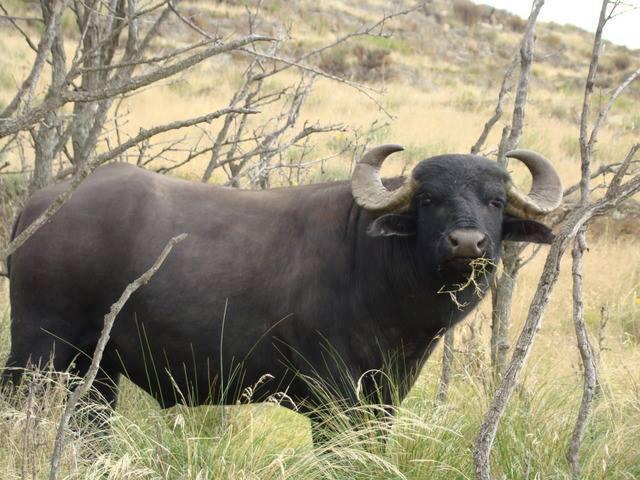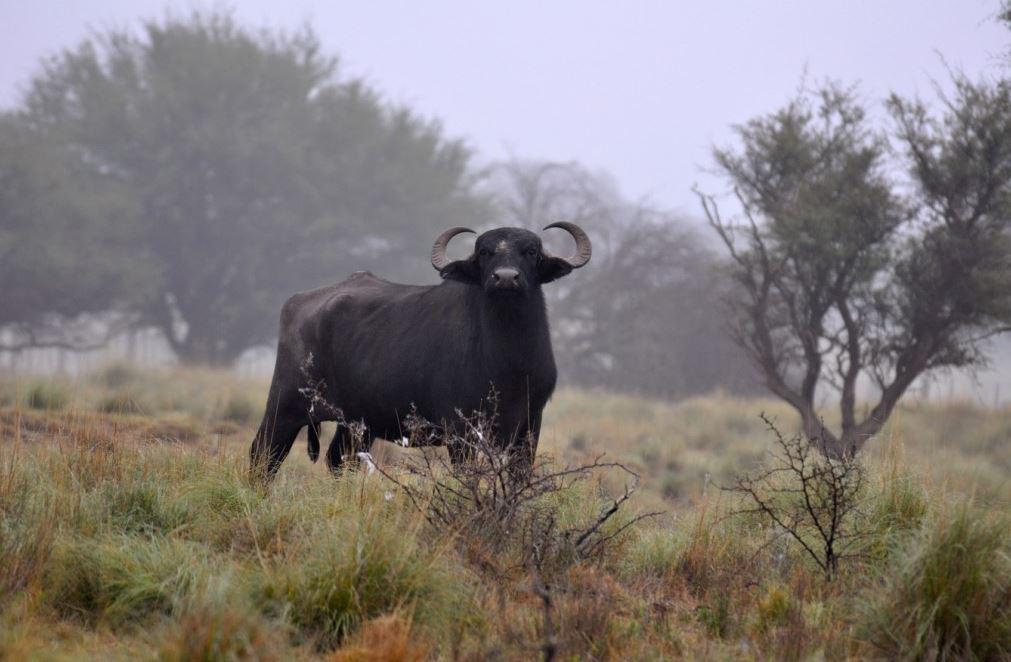The first image is the image on the left, the second image is the image on the right. Given the left and right images, does the statement "The left image features one camera-gazing water buffalo that is standing directly in front of a wet area." hold true? Answer yes or no. No. The first image is the image on the left, the second image is the image on the right. For the images displayed, is the sentence "There are exactly two African buffalo." factually correct? Answer yes or no. Yes. 